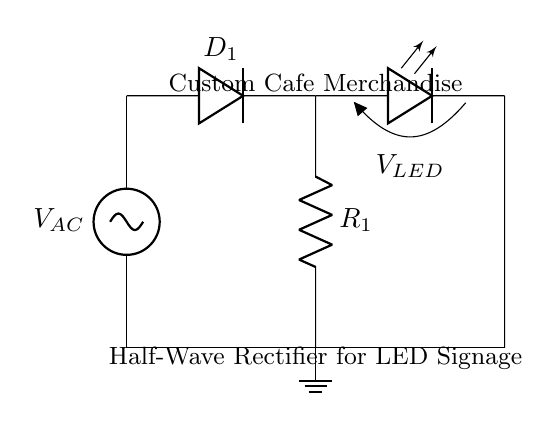What type of rectifier is shown in the circuit? The circuit is a half-wave rectifier, as indicated by the single diode allowing current through during one half of the AC cycle only.
Answer: Half-wave What component is used to convert AC to DC in the circuit? The component converting AC to DC is the diode, specifically denoted as D1 in the circuit, which allows current to flow in one direction only.
Answer: Diode How many resistors are present in the circuit? There is one resistor indicated as R1, which is necessary for current limiting to prevent damage to subsequent components like the LED.
Answer: One What is connected in parallel with the LED? The ground is connected in parallel with the LED, ensuring that the LED is illuminated consistently when the circuit is completed through the diode.
Answer: Ground What happens to the current during the off cycle of the AC source? During the off cycle, the diode blocks current flow, preventing any reverse current, which results in no power delivered to the LED.
Answer: No current What voltage is indicated across the LED in the circuit? The voltage across the LED is indicated as V_LED, which reflects the forward voltage drop required for the LED to emit light.
Answer: V_LED 